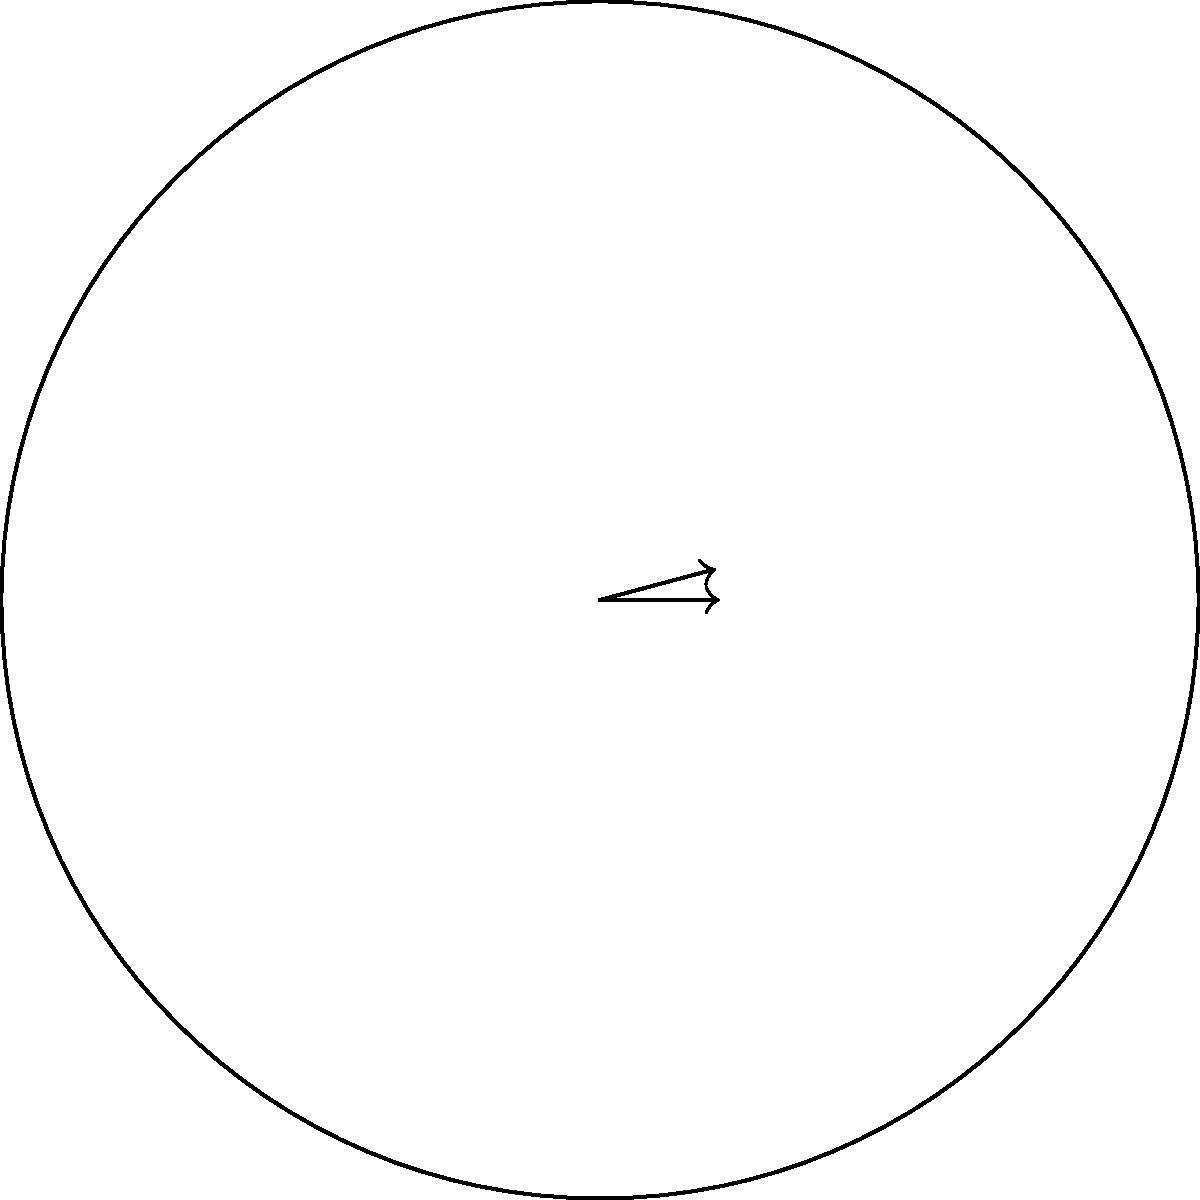You're designing a circular zoetrope for a stop-motion project. The zoetrope has a circumference of 120 cm and needs to accommodate 24 frames. What is the central angle $\theta$ (in degrees) between two adjacent frames? To find the central angle between two adjacent frames, we can follow these steps:

1) First, recall that the total angle in a circle is 360°.

2) The number of frames represents how many equal parts we're dividing the circle into.

3) To find the angle between two adjacent frames, we divide the total angle by the number of frames:

   $\theta = \frac{\text{Total angle}}{\text{Number of frames}}$

4) Substituting the values:

   $\theta = \frac{360°}{24}$

5) Simplify:

   $\theta = 15°$

Therefore, the central angle between two adjacent frames is 15°.

Note: The circumference given (120 cm) wasn't needed to solve this problem. The central angle depends only on the number of divisions (frames) in the circle, not on its size.
Answer: 15° 